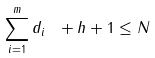Convert formula to latex. <formula><loc_0><loc_0><loc_500><loc_500>\sum _ { i = 1 } ^ { m } { d _ { i } } \ + h + 1 \leq N</formula> 